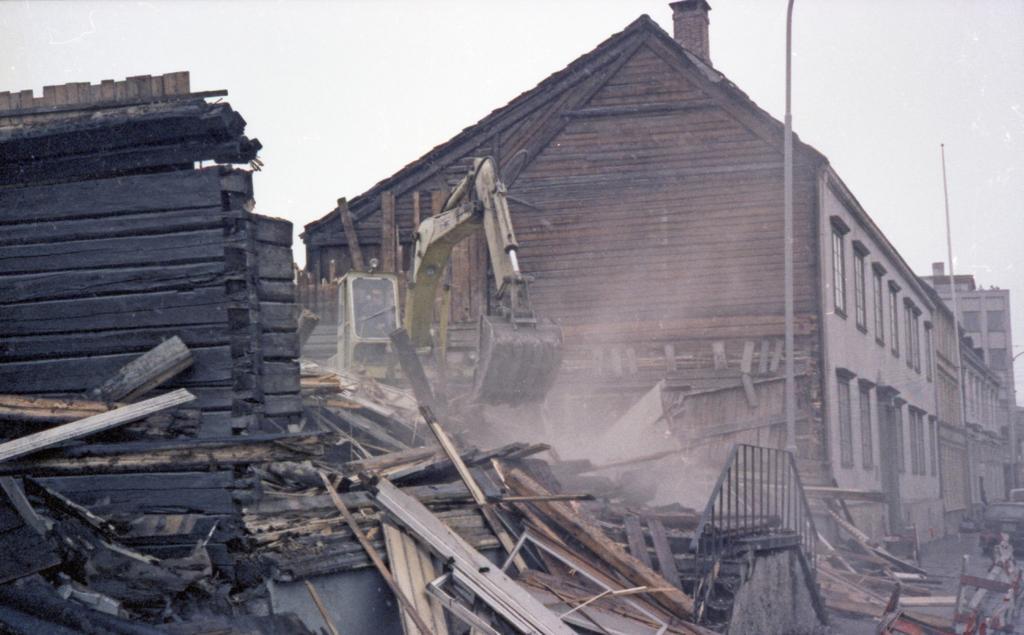Describe this image in one or two sentences. In this image there is the sky towards the top of the image, there are buildings, there are windows, there is a wall, there is a vehicle, there is a person sitting in the vehicle, there are poles, there is road towards the right of the image, there are vehicles on the road, there are wooden objects on the ground, there are wooden objects towards the left of the image. 